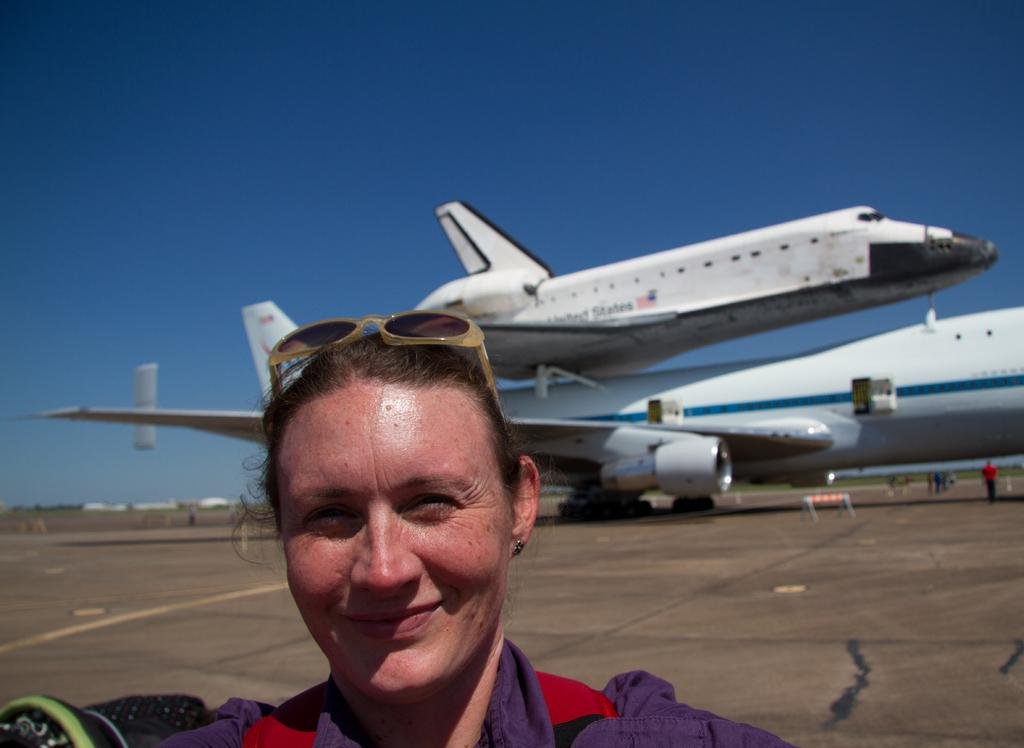Who is present in the image? There is a woman in the image. What is the woman's expression? The woman is smiling. What can be seen in the background of the image? There are planes and persons in the background of the image. What type of lipstick is the woman wearing in the image? There is no mention of lipstick or any makeup in the provided facts, so it cannot be determined from the image. 